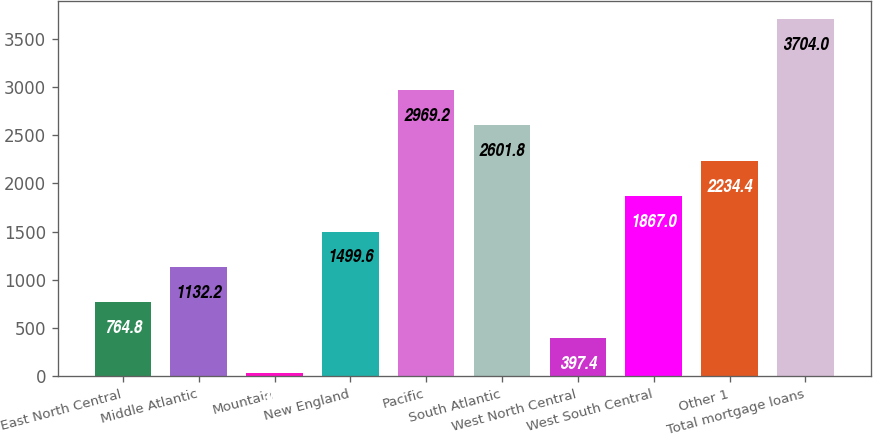<chart> <loc_0><loc_0><loc_500><loc_500><bar_chart><fcel>East North Central<fcel>Middle Atlantic<fcel>Mountain<fcel>New England<fcel>Pacific<fcel>South Atlantic<fcel>West North Central<fcel>West South Central<fcel>Other 1<fcel>Total mortgage loans<nl><fcel>764.8<fcel>1132.2<fcel>30<fcel>1499.6<fcel>2969.2<fcel>2601.8<fcel>397.4<fcel>1867<fcel>2234.4<fcel>3704<nl></chart> 